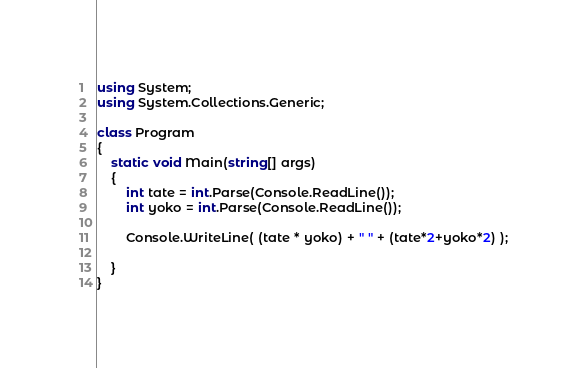<code> <loc_0><loc_0><loc_500><loc_500><_C#_>using System;
using System.Collections.Generic;

class Program
{
    static void Main(string[] args)
    {
        int tate = int.Parse(Console.ReadLine());
        int yoko = int.Parse(Console.ReadLine());

        Console.WriteLine( (tate * yoko) + " " + (tate*2+yoko*2) );

    }
}</code> 